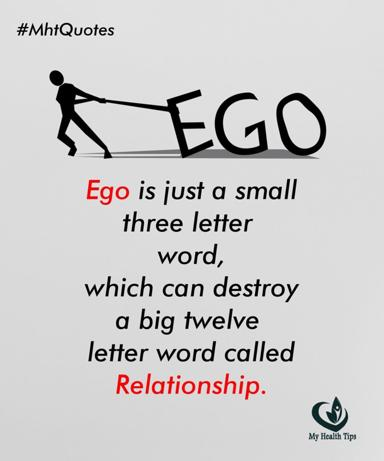What is the quote about ego and relationship in the image? The image displays a profound quote stating, "Ego is just a small three letter word, which can destroy a big twelve letter word called Relationship." This insightful message is featured under the hashtag #MhtQuotes, which suggests it's part of a series on health and relationship advice by My Health Tips. 